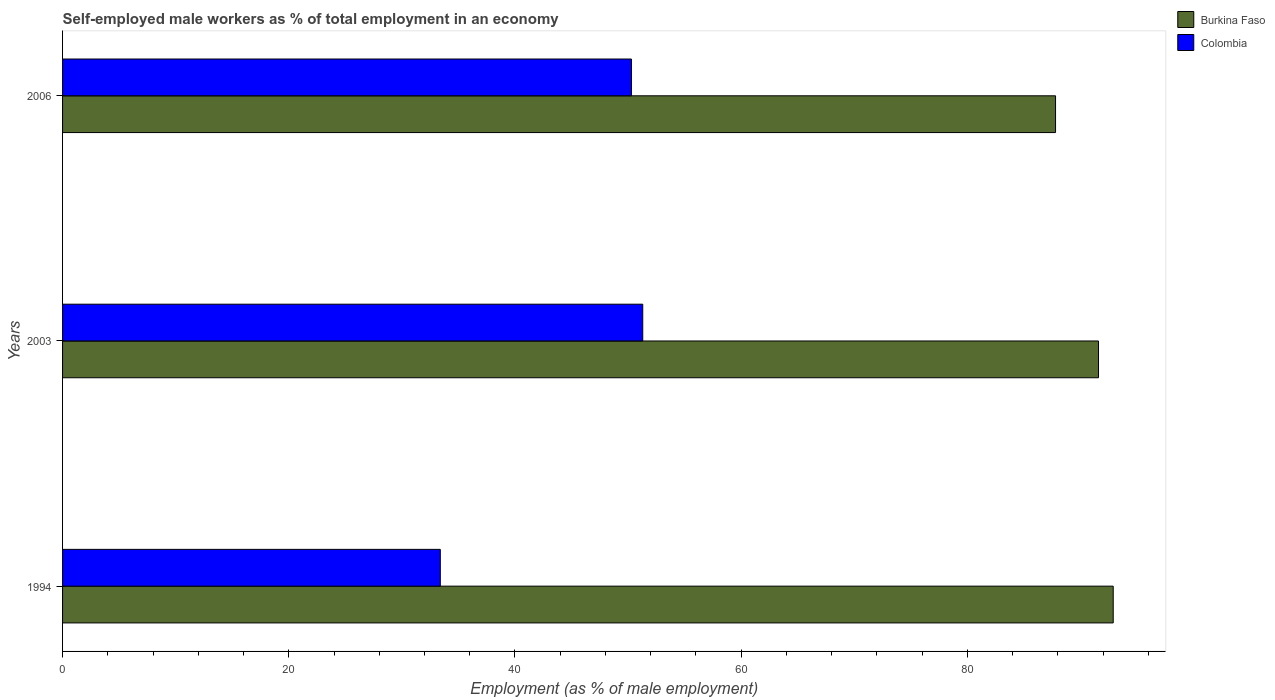How many groups of bars are there?
Keep it short and to the point. 3. Are the number of bars per tick equal to the number of legend labels?
Make the answer very short. Yes. Are the number of bars on each tick of the Y-axis equal?
Give a very brief answer. Yes. How many bars are there on the 3rd tick from the top?
Offer a terse response. 2. In how many cases, is the number of bars for a given year not equal to the number of legend labels?
Keep it short and to the point. 0. What is the percentage of self-employed male workers in Burkina Faso in 2003?
Your response must be concise. 91.6. Across all years, what is the maximum percentage of self-employed male workers in Colombia?
Offer a terse response. 51.3. Across all years, what is the minimum percentage of self-employed male workers in Burkina Faso?
Keep it short and to the point. 87.8. What is the total percentage of self-employed male workers in Colombia in the graph?
Your response must be concise. 135. What is the difference between the percentage of self-employed male workers in Colombia in 1994 and that in 2006?
Offer a terse response. -16.9. What is the difference between the percentage of self-employed male workers in Colombia in 2006 and the percentage of self-employed male workers in Burkina Faso in 2003?
Provide a short and direct response. -41.3. What is the average percentage of self-employed male workers in Colombia per year?
Ensure brevity in your answer.  45. In the year 2003, what is the difference between the percentage of self-employed male workers in Colombia and percentage of self-employed male workers in Burkina Faso?
Make the answer very short. -40.3. In how many years, is the percentage of self-employed male workers in Colombia greater than 44 %?
Offer a terse response. 2. What is the ratio of the percentage of self-employed male workers in Colombia in 1994 to that in 2003?
Offer a terse response. 0.65. Is the percentage of self-employed male workers in Colombia in 2003 less than that in 2006?
Offer a terse response. No. What is the difference between the highest and the lowest percentage of self-employed male workers in Colombia?
Provide a short and direct response. 17.9. In how many years, is the percentage of self-employed male workers in Burkina Faso greater than the average percentage of self-employed male workers in Burkina Faso taken over all years?
Provide a succinct answer. 2. What does the 2nd bar from the top in 2003 represents?
Provide a short and direct response. Burkina Faso. What does the 2nd bar from the bottom in 1994 represents?
Your answer should be very brief. Colombia. Are the values on the major ticks of X-axis written in scientific E-notation?
Your answer should be compact. No. Does the graph contain grids?
Offer a terse response. No. What is the title of the graph?
Give a very brief answer. Self-employed male workers as % of total employment in an economy. Does "Moldova" appear as one of the legend labels in the graph?
Give a very brief answer. No. What is the label or title of the X-axis?
Your answer should be compact. Employment (as % of male employment). What is the label or title of the Y-axis?
Keep it short and to the point. Years. What is the Employment (as % of male employment) of Burkina Faso in 1994?
Your answer should be very brief. 92.9. What is the Employment (as % of male employment) of Colombia in 1994?
Your answer should be compact. 33.4. What is the Employment (as % of male employment) in Burkina Faso in 2003?
Keep it short and to the point. 91.6. What is the Employment (as % of male employment) in Colombia in 2003?
Offer a terse response. 51.3. What is the Employment (as % of male employment) of Burkina Faso in 2006?
Make the answer very short. 87.8. What is the Employment (as % of male employment) of Colombia in 2006?
Your answer should be compact. 50.3. Across all years, what is the maximum Employment (as % of male employment) in Burkina Faso?
Your answer should be very brief. 92.9. Across all years, what is the maximum Employment (as % of male employment) of Colombia?
Provide a short and direct response. 51.3. Across all years, what is the minimum Employment (as % of male employment) of Burkina Faso?
Make the answer very short. 87.8. Across all years, what is the minimum Employment (as % of male employment) of Colombia?
Your answer should be compact. 33.4. What is the total Employment (as % of male employment) in Burkina Faso in the graph?
Keep it short and to the point. 272.3. What is the total Employment (as % of male employment) in Colombia in the graph?
Your response must be concise. 135. What is the difference between the Employment (as % of male employment) of Colombia in 1994 and that in 2003?
Your response must be concise. -17.9. What is the difference between the Employment (as % of male employment) of Burkina Faso in 1994 and that in 2006?
Ensure brevity in your answer.  5.1. What is the difference between the Employment (as % of male employment) in Colombia in 1994 and that in 2006?
Make the answer very short. -16.9. What is the difference between the Employment (as % of male employment) in Colombia in 2003 and that in 2006?
Keep it short and to the point. 1. What is the difference between the Employment (as % of male employment) in Burkina Faso in 1994 and the Employment (as % of male employment) in Colombia in 2003?
Provide a succinct answer. 41.6. What is the difference between the Employment (as % of male employment) of Burkina Faso in 1994 and the Employment (as % of male employment) of Colombia in 2006?
Give a very brief answer. 42.6. What is the difference between the Employment (as % of male employment) of Burkina Faso in 2003 and the Employment (as % of male employment) of Colombia in 2006?
Provide a short and direct response. 41.3. What is the average Employment (as % of male employment) of Burkina Faso per year?
Keep it short and to the point. 90.77. In the year 1994, what is the difference between the Employment (as % of male employment) in Burkina Faso and Employment (as % of male employment) in Colombia?
Give a very brief answer. 59.5. In the year 2003, what is the difference between the Employment (as % of male employment) of Burkina Faso and Employment (as % of male employment) of Colombia?
Provide a succinct answer. 40.3. In the year 2006, what is the difference between the Employment (as % of male employment) of Burkina Faso and Employment (as % of male employment) of Colombia?
Ensure brevity in your answer.  37.5. What is the ratio of the Employment (as % of male employment) in Burkina Faso in 1994 to that in 2003?
Give a very brief answer. 1.01. What is the ratio of the Employment (as % of male employment) in Colombia in 1994 to that in 2003?
Your answer should be compact. 0.65. What is the ratio of the Employment (as % of male employment) in Burkina Faso in 1994 to that in 2006?
Your answer should be very brief. 1.06. What is the ratio of the Employment (as % of male employment) of Colombia in 1994 to that in 2006?
Keep it short and to the point. 0.66. What is the ratio of the Employment (as % of male employment) of Burkina Faso in 2003 to that in 2006?
Give a very brief answer. 1.04. What is the ratio of the Employment (as % of male employment) in Colombia in 2003 to that in 2006?
Offer a very short reply. 1.02. What is the difference between the highest and the second highest Employment (as % of male employment) in Colombia?
Provide a short and direct response. 1. What is the difference between the highest and the lowest Employment (as % of male employment) of Colombia?
Your answer should be very brief. 17.9. 